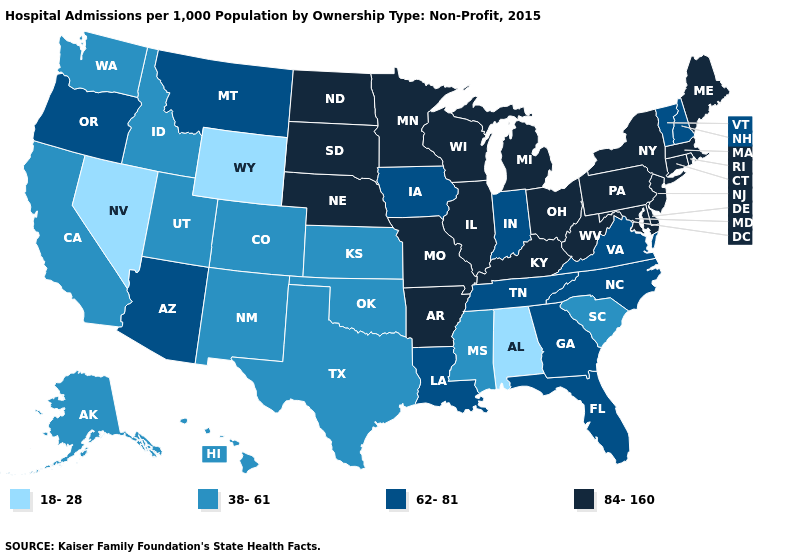Does California have the same value as Georgia?
Quick response, please. No. Name the states that have a value in the range 38-61?
Short answer required. Alaska, California, Colorado, Hawaii, Idaho, Kansas, Mississippi, New Mexico, Oklahoma, South Carolina, Texas, Utah, Washington. Name the states that have a value in the range 38-61?
Quick response, please. Alaska, California, Colorado, Hawaii, Idaho, Kansas, Mississippi, New Mexico, Oklahoma, South Carolina, Texas, Utah, Washington. Name the states that have a value in the range 38-61?
Answer briefly. Alaska, California, Colorado, Hawaii, Idaho, Kansas, Mississippi, New Mexico, Oklahoma, South Carolina, Texas, Utah, Washington. Name the states that have a value in the range 18-28?
Write a very short answer. Alabama, Nevada, Wyoming. Does West Virginia have the highest value in the USA?
Write a very short answer. Yes. Does South Dakota have the lowest value in the USA?
Short answer required. No. What is the value of Indiana?
Keep it brief. 62-81. What is the lowest value in states that border Kansas?
Short answer required. 38-61. What is the lowest value in the West?
Answer briefly. 18-28. Among the states that border Rhode Island , which have the lowest value?
Concise answer only. Connecticut, Massachusetts. Which states hav the highest value in the MidWest?
Concise answer only. Illinois, Michigan, Minnesota, Missouri, Nebraska, North Dakota, Ohio, South Dakota, Wisconsin. Name the states that have a value in the range 38-61?
Quick response, please. Alaska, California, Colorado, Hawaii, Idaho, Kansas, Mississippi, New Mexico, Oklahoma, South Carolina, Texas, Utah, Washington. Is the legend a continuous bar?
Give a very brief answer. No. What is the lowest value in the USA?
Write a very short answer. 18-28. 